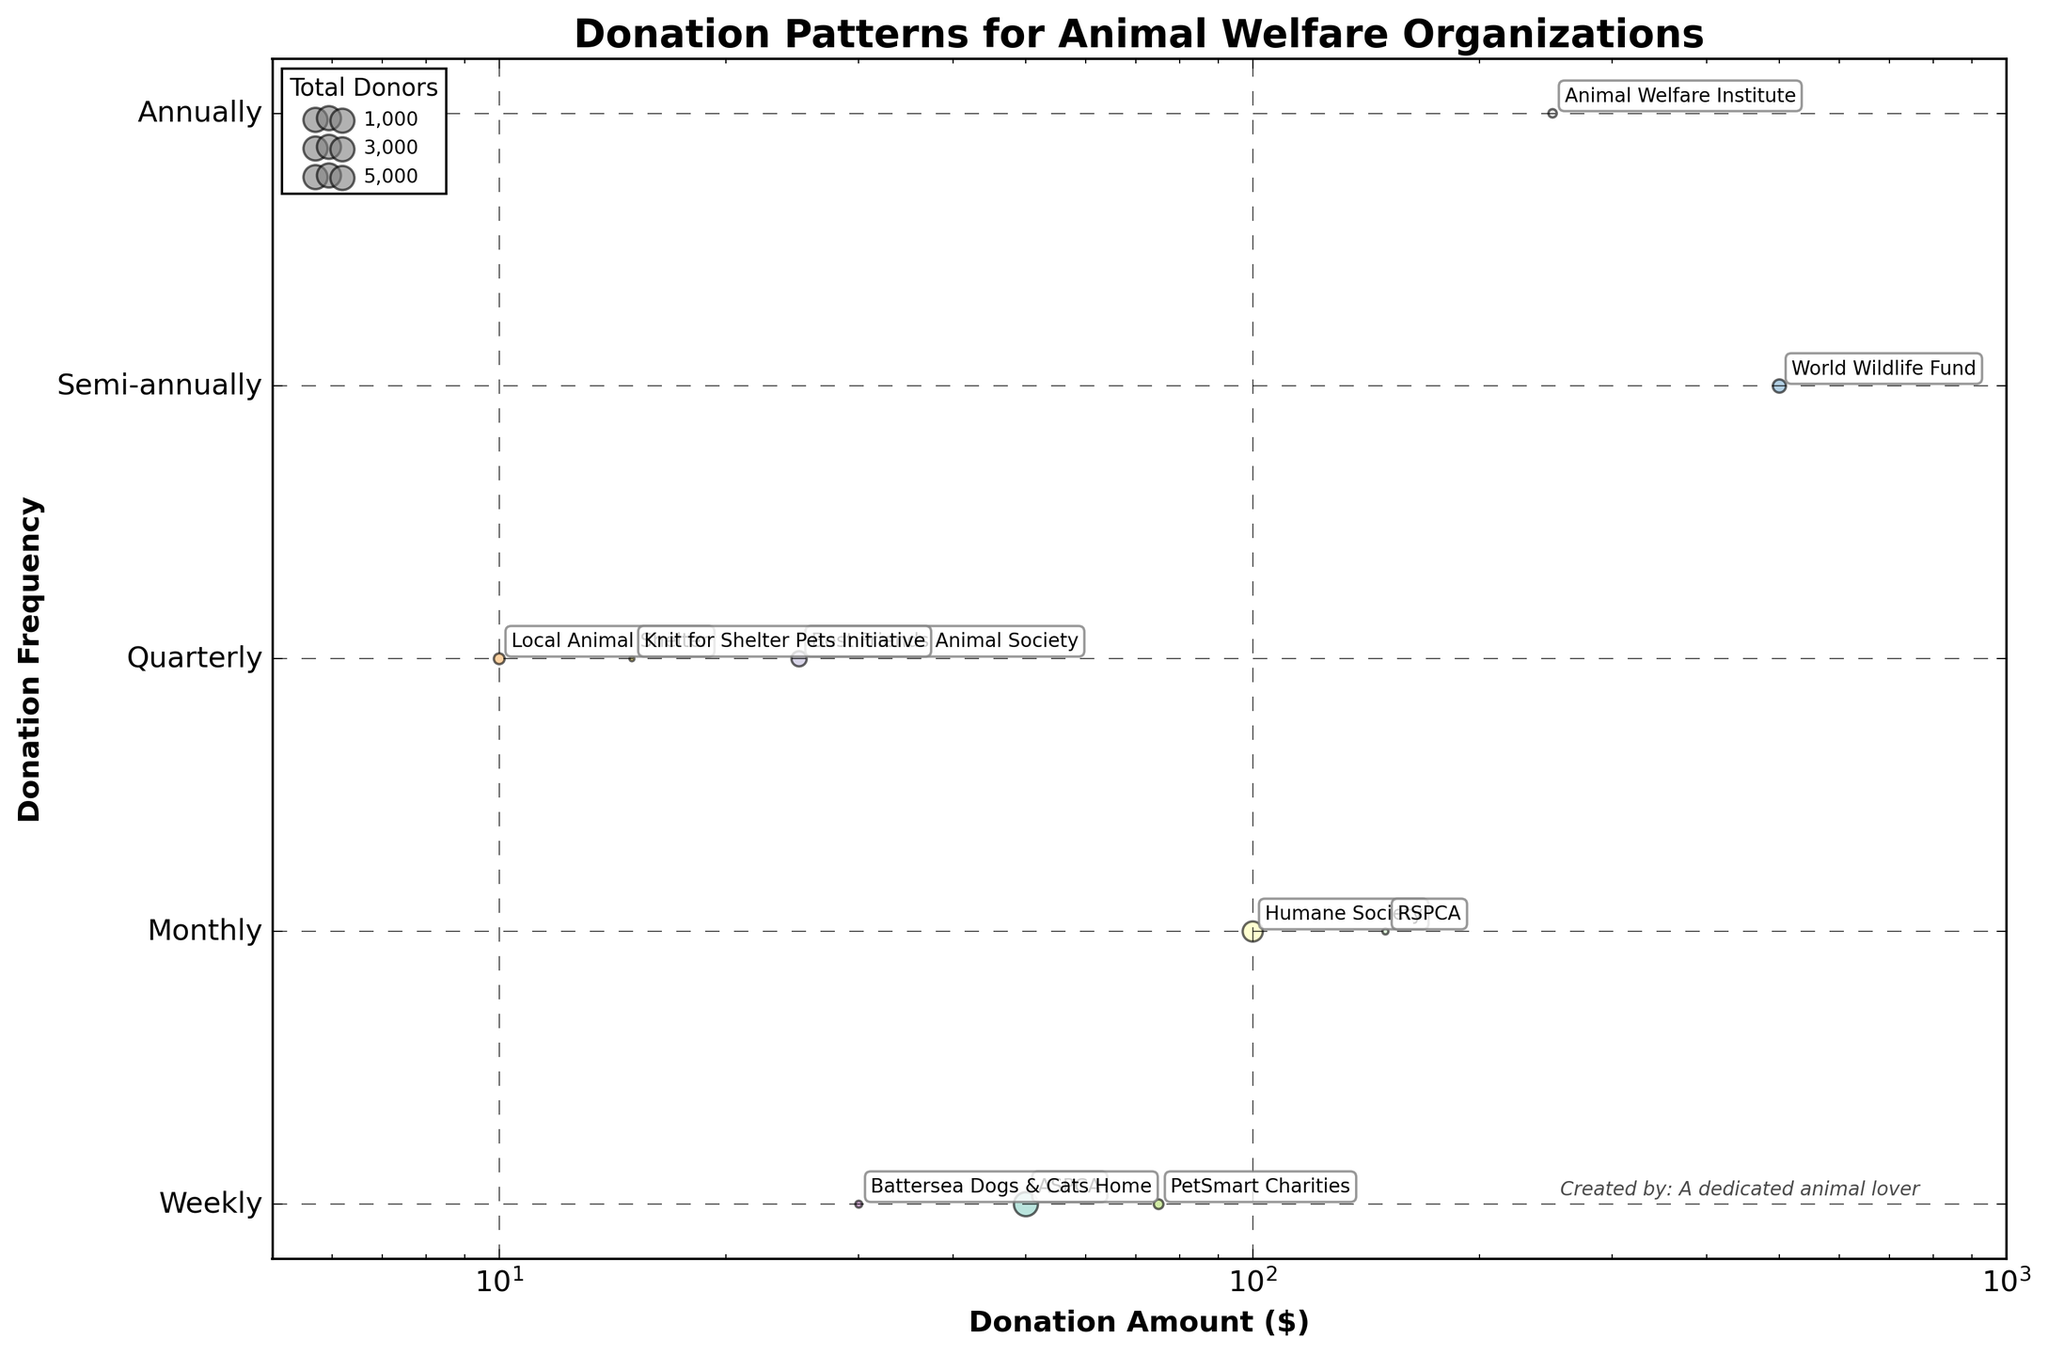How many organizations have a total donor count represented by a bubble size close to 40? The legend suggests bubble sizes of approximately 20, 60, and 100, so we can deduce 40 is between the smallest and medium bubbles. By looking at bubble sizes, organizations like Humane Society, Best Friends Animal Society, and ASPCA are close to this size. This gives us at least three organizations.
Answer: Three Which organization donates the highest amount annually? Whether labeled or not, we observe different donation frequencies and amounts. By comparing amounts, World Wildlife Fund has the highest at $500 and is marked annually.
Answer: World Wildlife Fund What is the range of donation frequencies represented? The y-axis text labels frequency steps, such as Weekly, Monthly, Quarterly, Semi-annually, and Annually. These are the frequencies present in the plot.
Answer: Weekly to Annually How does the donation pattern of the ASPCA compare to PetSmart Charities? For ASPCA, the bubble is at $50 (monthly), comparing to the $75 (monthly) PetSmart Charities bubble, ASPCA has a lower donation amount but more donors as the bubble is bigger.
Answer: ASPCA has more donors but a lower donation amount Which organization has the smallest total donation amount, and how frequently does it donate? By observing the smallest bubble, Local Animal Shelter donates $10 at the frequency indicated by its position which is weekly.
Answer: Local Animal Shelter, Weekly What's the total number of donors for Best Friends Animal Society and Knit for Shelter Pets Initiative combined? From observing bubble size and annotation, Best Friends Animal Society has 2000 donors, and Knit for Shelter Pets Initiative has 200, therefore summing them gives us 2200 donors.
Answer: 2200 What can you say about Animal Welfare Institute’s donation pattern? We see its bubble at $250 on the y-axis label, Semi-annually. The bubble size indicates fewer donors compared to others, visualizing just 600 donors.
Answer: $250 Semi-annually, with fewer donors How does the average donation amount differ between weekly donors Best Friends Animal Society and Local Animal Shelter? Best Friends Animal Society donates $25 weekly and Local Animal Shelter $10 weekly. Calculating the average (25+10)/2, gives $17.50
Answer: $17.50 Which frequent donation pattern has the greatest variation in donation amounts? By scanning the plot, every frequency level we see, but “weekly” contains the widest range from $10 to $25, indicating varied amounts among weekly donors.
Answer: Weekly How many organizations donate amounts $100 or greater? Listing donation amounts from bubbles labeled $100 or more, we see Humane Society ($100), RSPCA ($150), Animal Welfare Institute ($250), and World Wildlife Fund ($500), giving us 4 organizations.
Answer: Four 